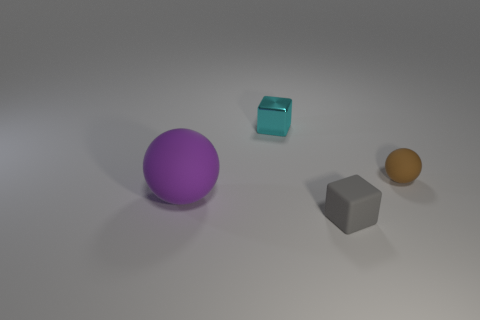Can you tell me the colors of all objects in the image from left to right? From left to right, the objects in the image are: a purple sphere, a cyan cube, a grey cube, and an orange sphere. 